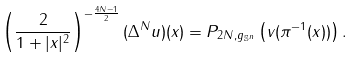<formula> <loc_0><loc_0><loc_500><loc_500>\left ( \frac { 2 } { 1 + | x | ^ { 2 } } \right ) ^ { - \frac { 4 N - 1 } { 2 } } ( \Delta ^ { N } u ) ( x ) = P _ { 2 N , g _ { \mathbb { S } ^ { n } } } \left ( v ( \pi ^ { - 1 } ( x ) ) \right ) .</formula> 